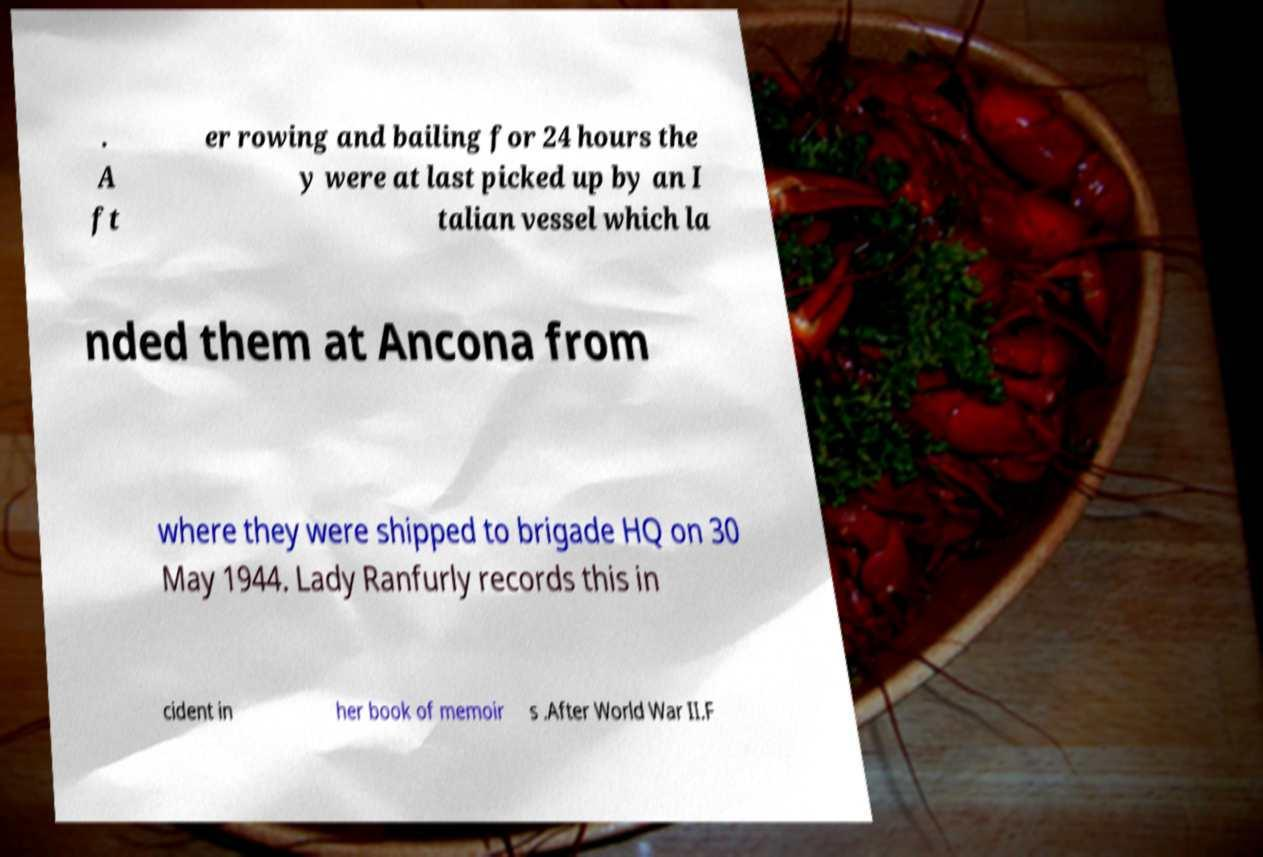There's text embedded in this image that I need extracted. Can you transcribe it verbatim? . A ft er rowing and bailing for 24 hours the y were at last picked up by an I talian vessel which la nded them at Ancona from where they were shipped to brigade HQ on 30 May 1944. Lady Ranfurly records this in cident in her book of memoir s .After World War II.F 